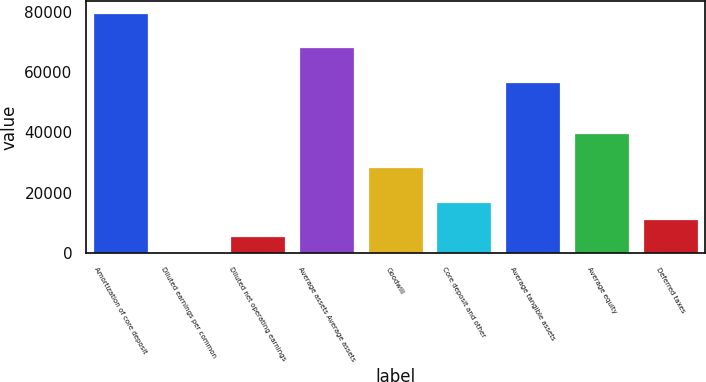<chart> <loc_0><loc_0><loc_500><loc_500><bar_chart><fcel>Amortization of core deposit<fcel>Diluted earnings per common<fcel>Diluted net operating earnings<fcel>Average assets Average assets<fcel>Goodwill<fcel>Core deposit and other<fcel>Average tangible assets<fcel>Average equity<fcel>Deferred taxes<nl><fcel>79524.4<fcel>6.73<fcel>5686.56<fcel>68164.7<fcel>28405.9<fcel>17046.2<fcel>56805<fcel>39765.5<fcel>11366.4<nl></chart> 